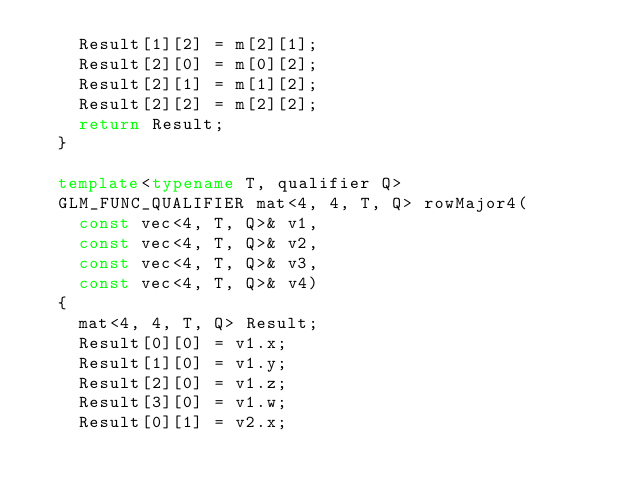Convert code to text. <code><loc_0><loc_0><loc_500><loc_500><_C++_>		Result[1][2] = m[2][1];
		Result[2][0] = m[0][2];
		Result[2][1] = m[1][2];
		Result[2][2] = m[2][2];
		return Result;
	}

	template<typename T, qualifier Q> 
	GLM_FUNC_QUALIFIER mat<4, 4, T, Q> rowMajor4(
		const vec<4, T, Q>& v1, 
		const vec<4, T, Q>& v2, 
		const vec<4, T, Q>& v3, 
		const vec<4, T, Q>& v4)
	{
		mat<4, 4, T, Q> Result;
		Result[0][0] = v1.x;
		Result[1][0] = v1.y;
		Result[2][0] = v1.z;
		Result[3][0] = v1.w;
		Result[0][1] = v2.x;</code> 